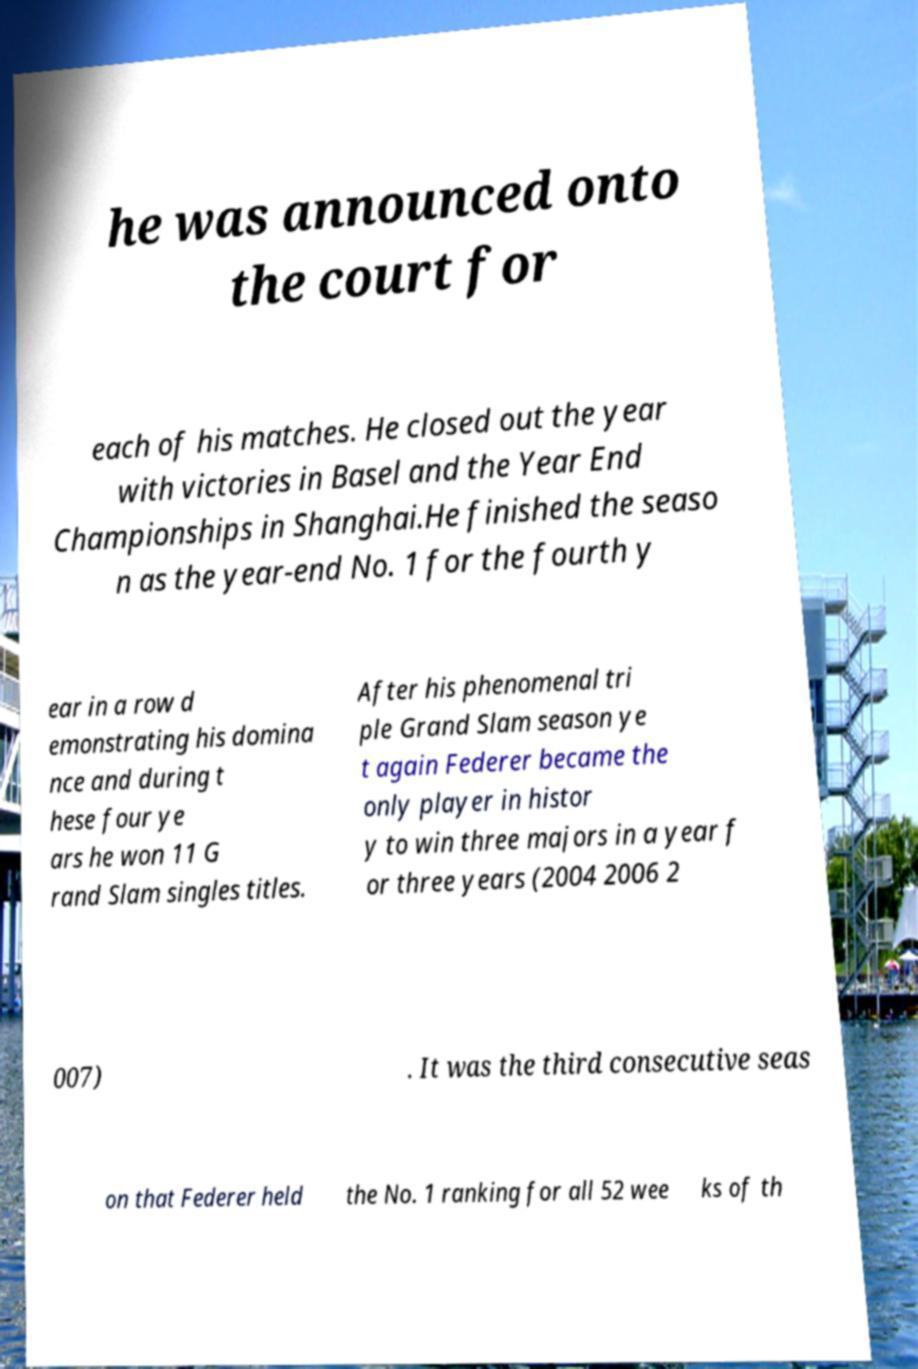Could you extract and type out the text from this image? he was announced onto the court for each of his matches. He closed out the year with victories in Basel and the Year End Championships in Shanghai.He finished the seaso n as the year-end No. 1 for the fourth y ear in a row d emonstrating his domina nce and during t hese four ye ars he won 11 G rand Slam singles titles. After his phenomenal tri ple Grand Slam season ye t again Federer became the only player in histor y to win three majors in a year f or three years (2004 2006 2 007) . It was the third consecutive seas on that Federer held the No. 1 ranking for all 52 wee ks of th 